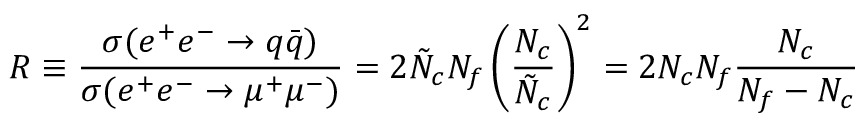Convert formula to latex. <formula><loc_0><loc_0><loc_500><loc_500>R \equiv \frac { \sigma ( e ^ { + } e ^ { - } \rightarrow q \bar { q } ) } { \sigma ( e ^ { + } e ^ { - } \rightarrow \mu ^ { + } \mu ^ { - } ) } = 2 \tilde { N } _ { c } N _ { f } \left ( \frac { N _ { c } } { \tilde { N } _ { c } } \right ) ^ { 2 } = 2 N _ { c } N _ { f } \frac { N _ { c } } { N _ { f } - N _ { c } }</formula> 